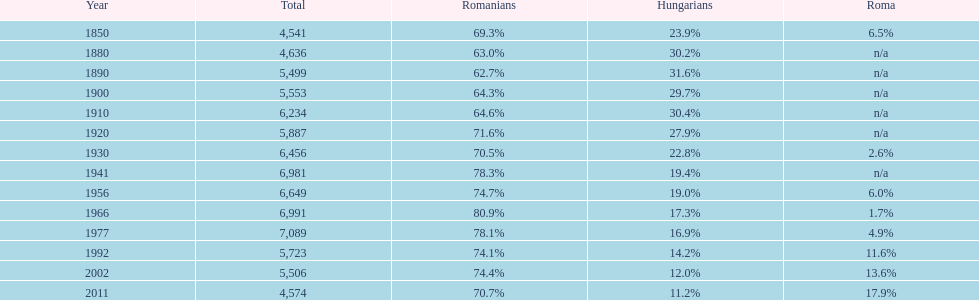In how many cases did the entire population amount to 6,000 or above? 6. 